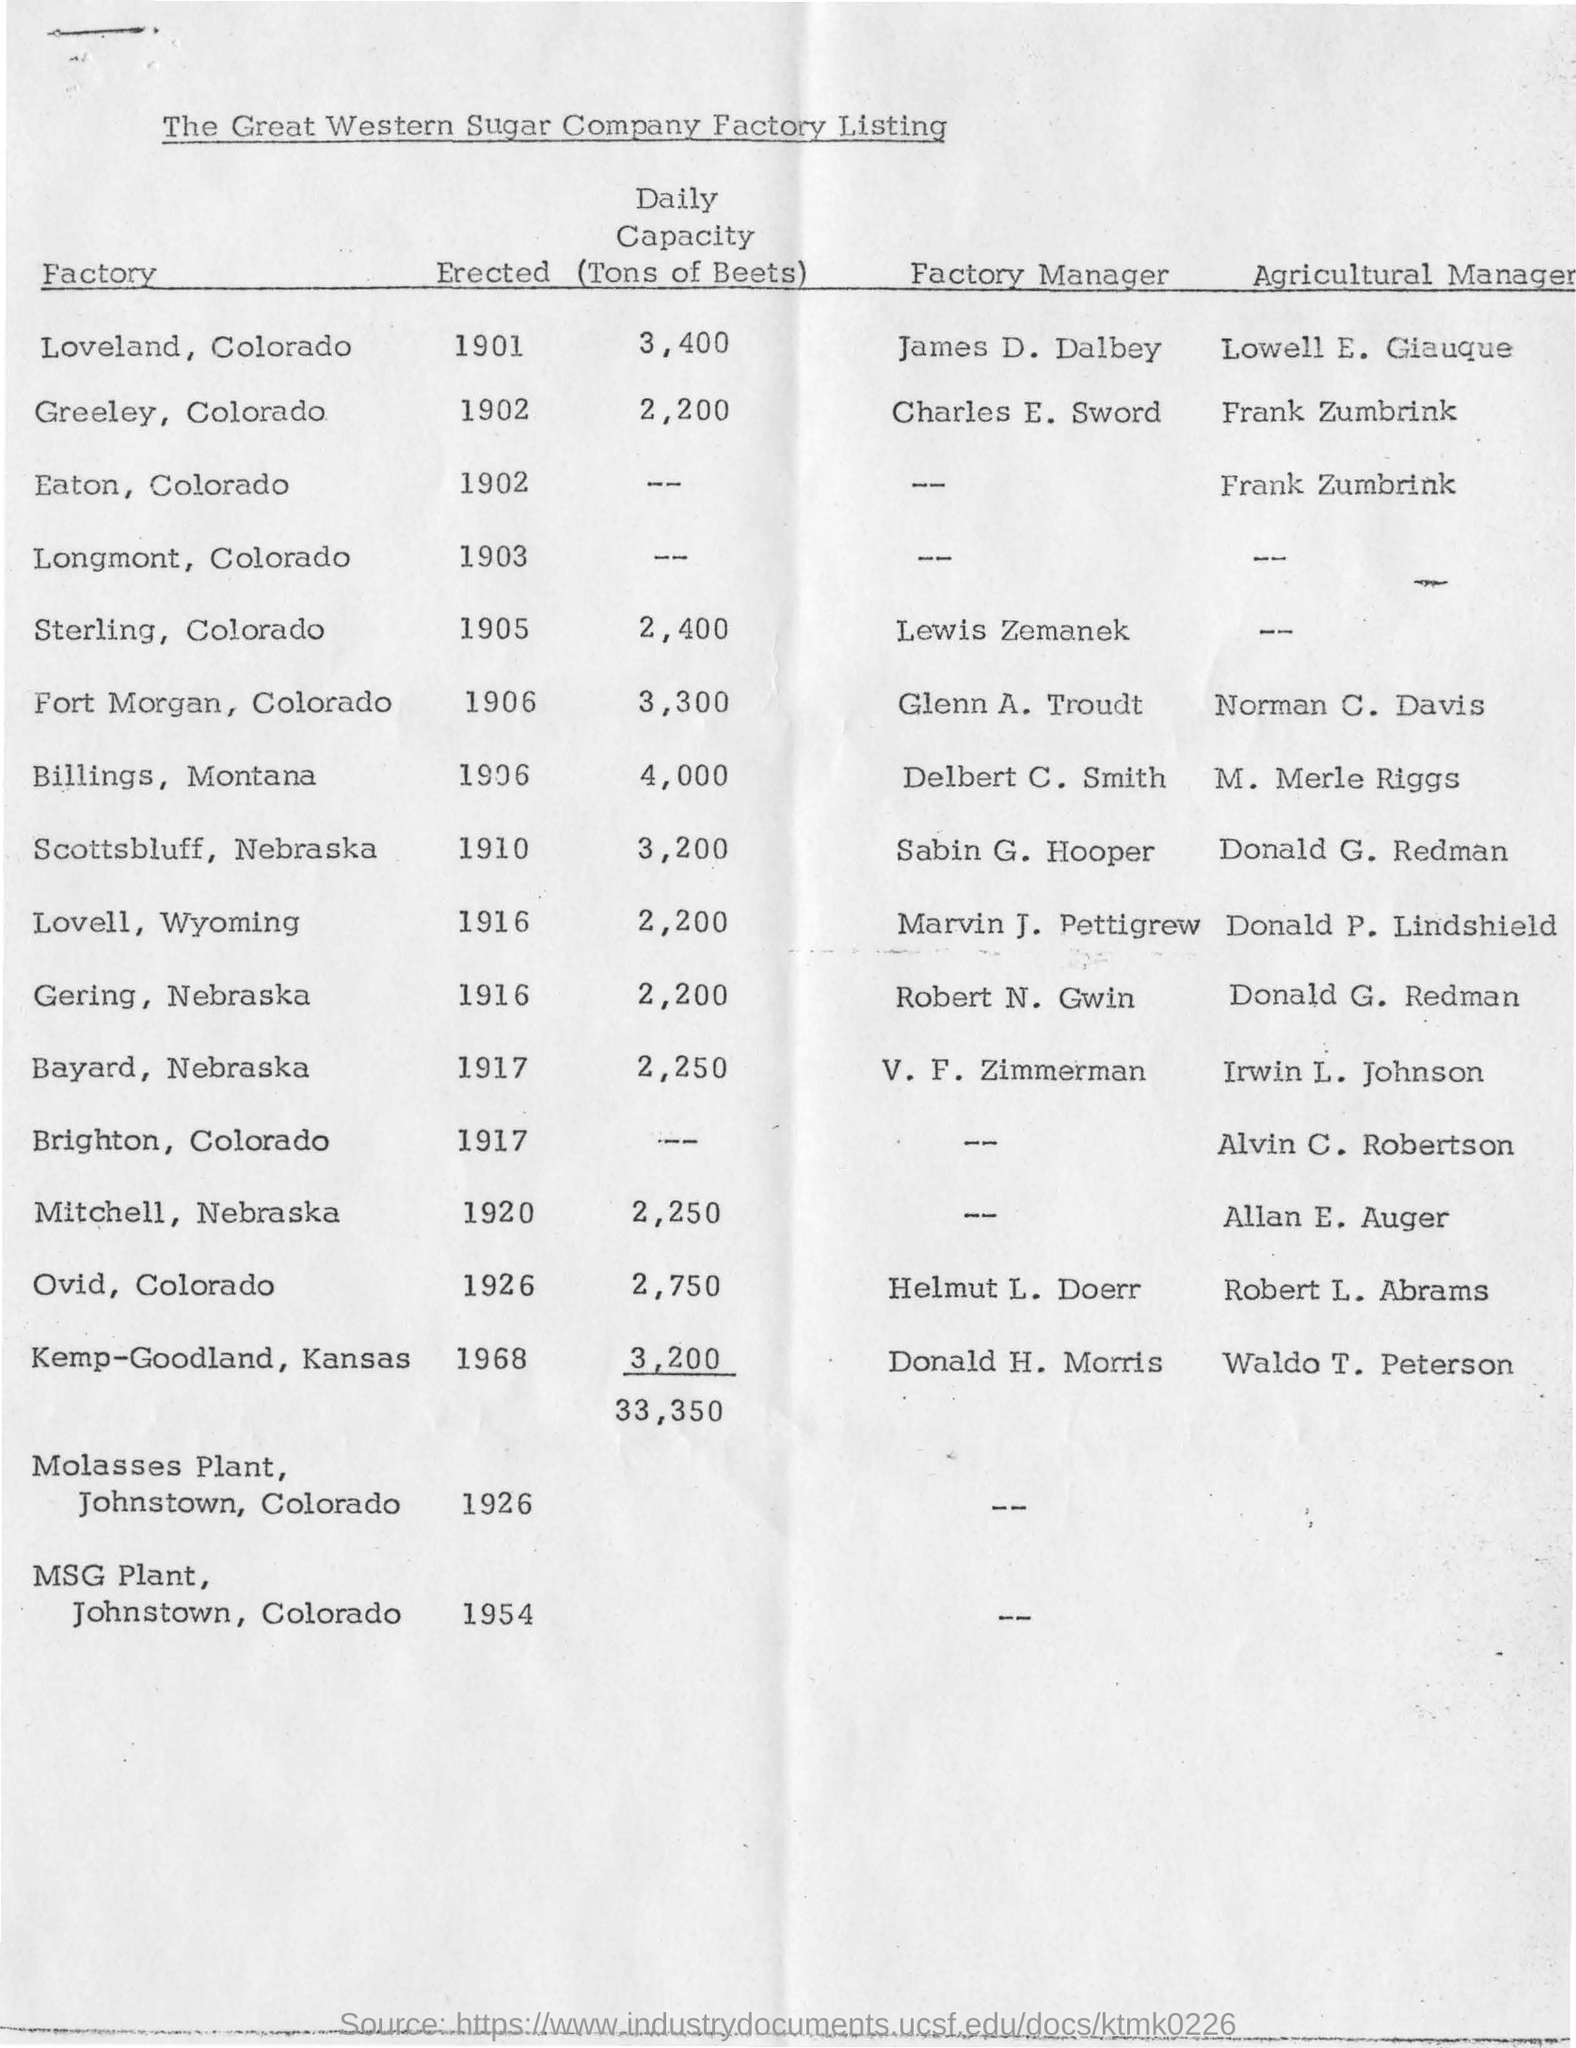When was loveland colorado factory erected?
Ensure brevity in your answer.  1901. What is the daily capacity of loveland, colorado factory?
Keep it short and to the point. 3400. Who is the factory manager of loveland, colorado?
Ensure brevity in your answer.  James d. dalbey. 